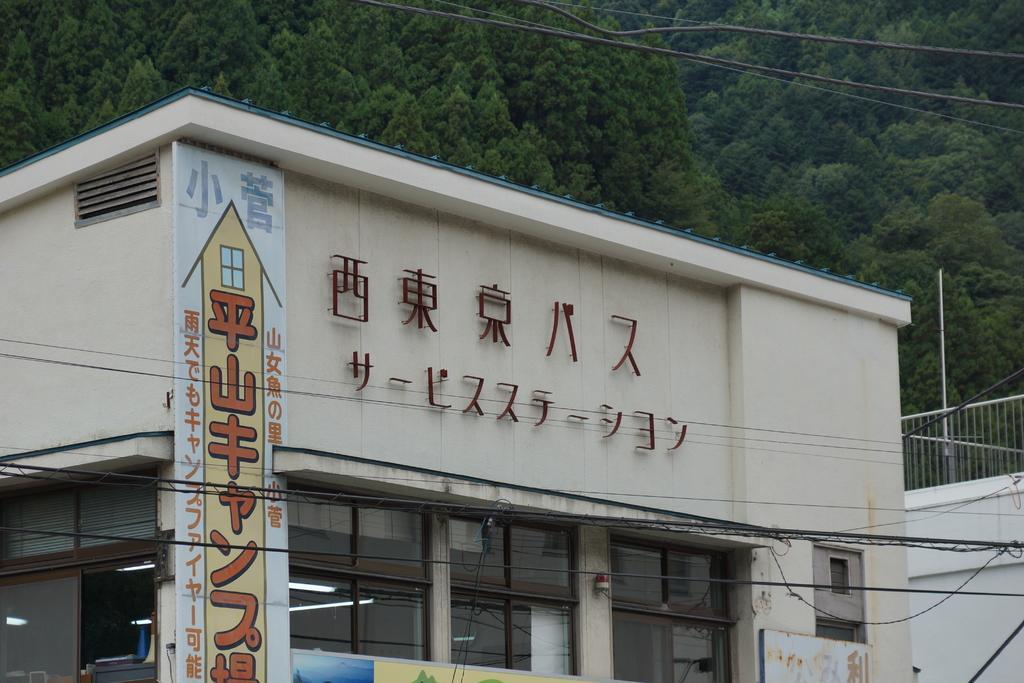How would you summarize this image in a sentence or two? In this image we can see building, grills, electric lights, electric cables and trees. 